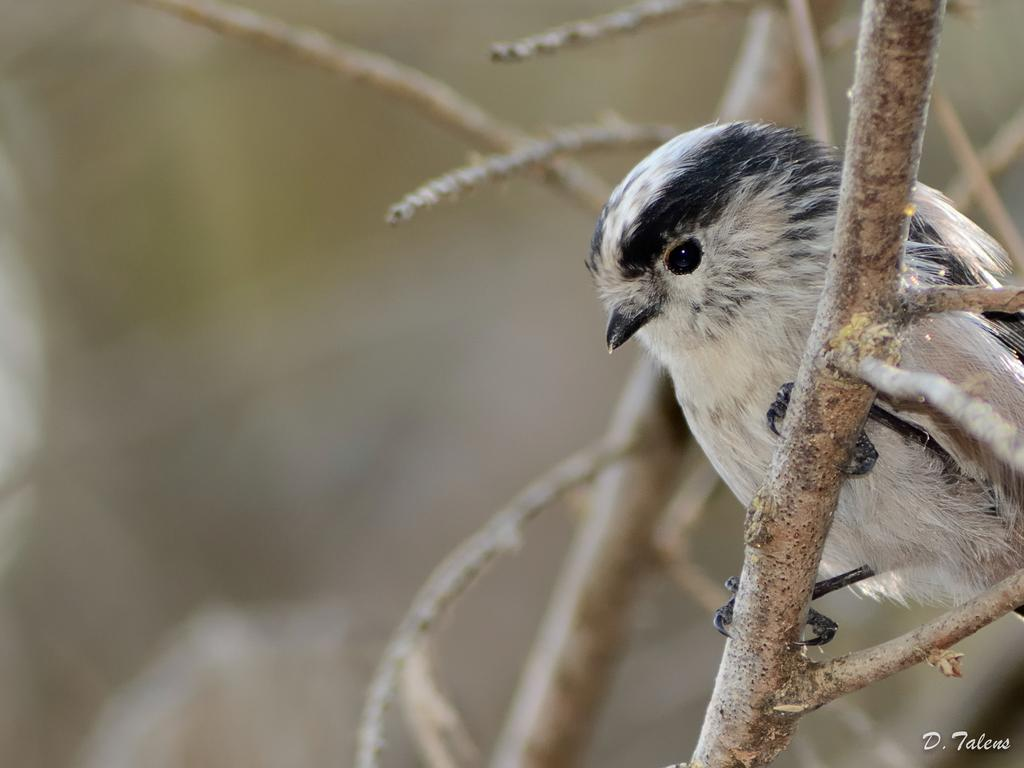What type of animal is in the picture? There is a small bird in the picture. What is the bird standing on? The bird is standing on a stem with twigs. Can you describe the bird's color? The bird has a white color with black shades. What show is the bird performing in the image? There is no show or performance depicted in the image; it simply shows a bird standing on a stem with twigs. 